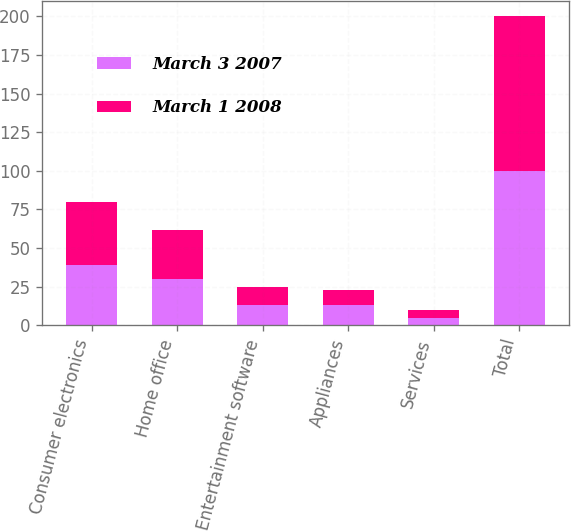Convert chart. <chart><loc_0><loc_0><loc_500><loc_500><stacked_bar_chart><ecel><fcel>Consumer electronics<fcel>Home office<fcel>Entertainment software<fcel>Appliances<fcel>Services<fcel>Total<nl><fcel>March 3 2007<fcel>39<fcel>30<fcel>13<fcel>13<fcel>5<fcel>100<nl><fcel>March 1 2008<fcel>41<fcel>32<fcel>12<fcel>10<fcel>5<fcel>100<nl></chart> 